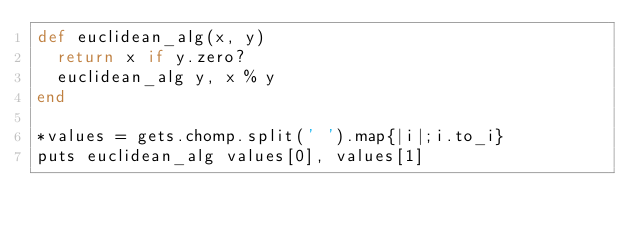<code> <loc_0><loc_0><loc_500><loc_500><_Ruby_>def euclidean_alg(x, y)
  return x if y.zero?
  euclidean_alg y, x % y
end

*values = gets.chomp.split(' ').map{|i|;i.to_i}
puts euclidean_alg values[0], values[1]

</code> 